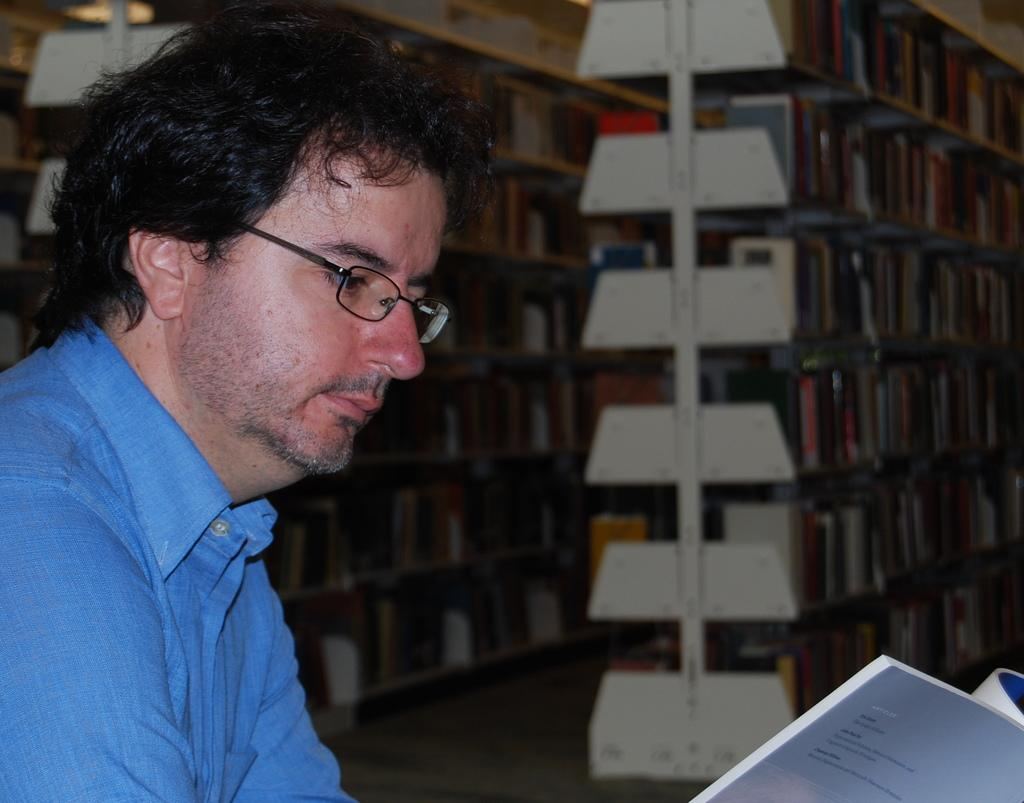Who is present in the image? There is a person in the image. What is the person holding? The person is holding a book. What is the person wearing? The person is wearing a blue dress. What can be seen in the background of the image? There are book racks visible in the background. How many lizards are sitting on the person's shoulder in the image? There are no lizards present in the image. 